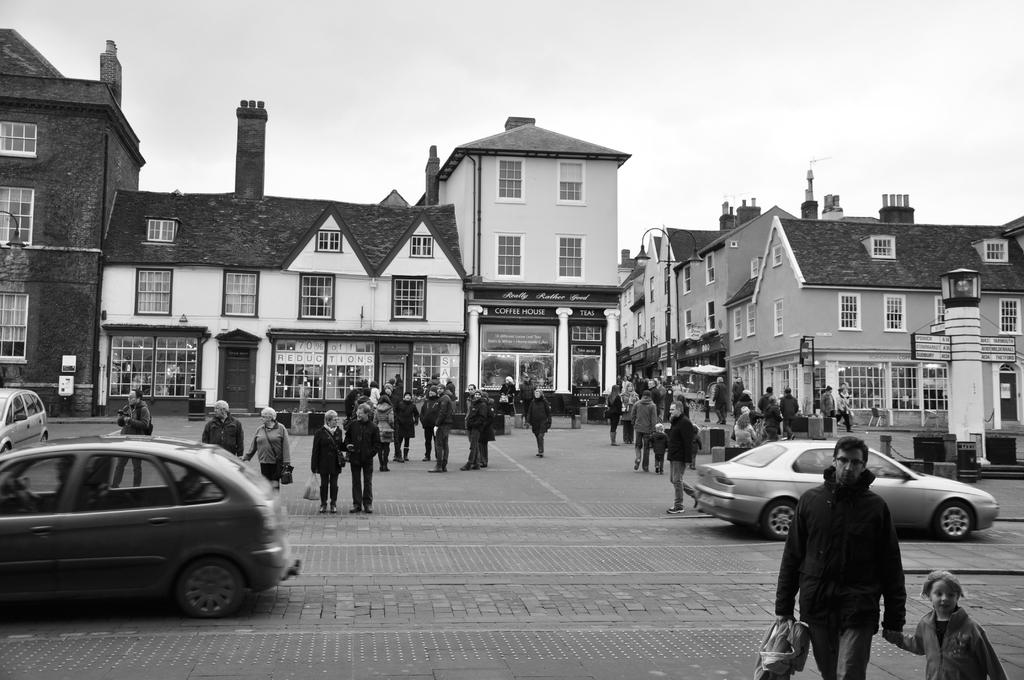What is the color scheme of the image? The image is black and white. What can be seen in the image besides the color scheme? There are people wearing clothes and cars in front of buildings in the image. What is visible at the top of the image? The sky is visible at the top of the image. What type of insurance policy is being discussed by the people in the image? There is no indication in the image that the people are discussing any insurance policies. 